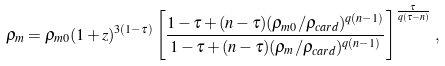Convert formula to latex. <formula><loc_0><loc_0><loc_500><loc_500>\rho _ { m } = \rho _ { m 0 } ( 1 + z ) ^ { 3 ( 1 - \tau ) } \left [ \frac { 1 - \tau + ( n - \tau ) ( \rho _ { m 0 } / \rho _ { c a r d } ) ^ { q ( n - 1 ) } } { 1 - \tau + ( n - \tau ) ( \rho _ { m } / \rho _ { c a r d } ) ^ { q ( n - 1 ) } } \right ] ^ { \frac { \tau } { q ( \tau - n ) } } \, ,</formula> 